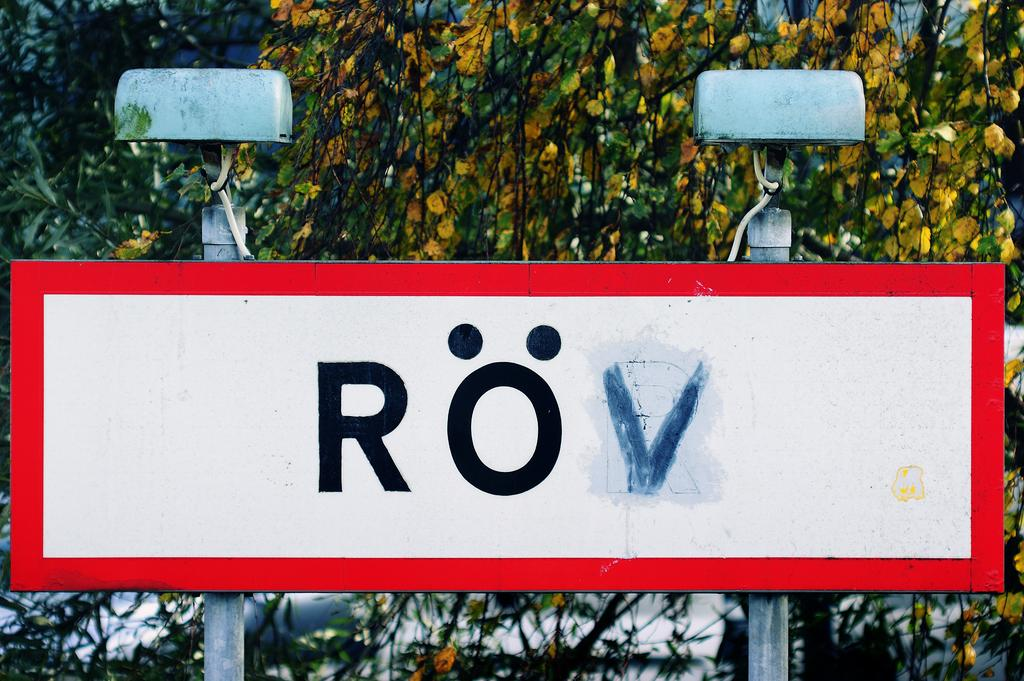What is the main object in the image? There is a board in the image. How is the board supported? The board is fixed to poles. What can be seen on the board? There is text on the board. What can be seen in the background of the image? There are plants in the background of the image. What other objects are present near the board? There are routers above the poles. Who is the expert on the board in the image? There is no expert present on the board in the image. What type of twig can be seen growing near the board? There is no twig visible in the image; only plants are mentioned in the background. 